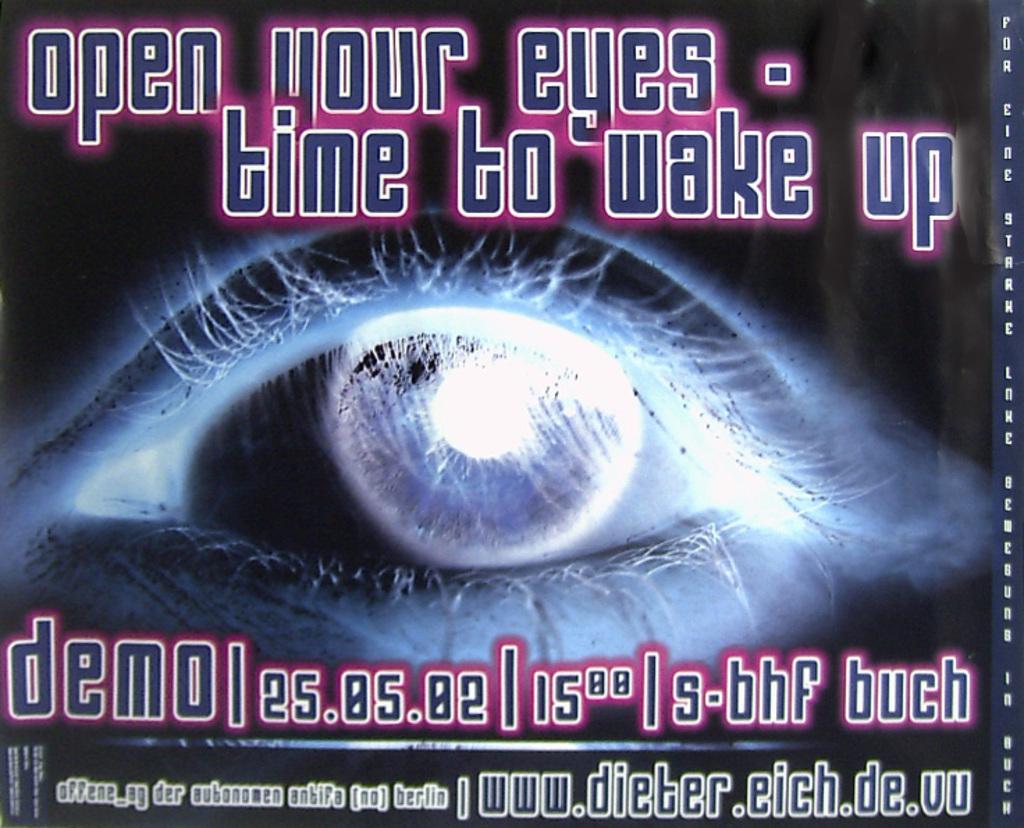What is it time to do?
Provide a short and direct response. Wake up. What is the date of this event/?
Offer a terse response. 25.05.02. 